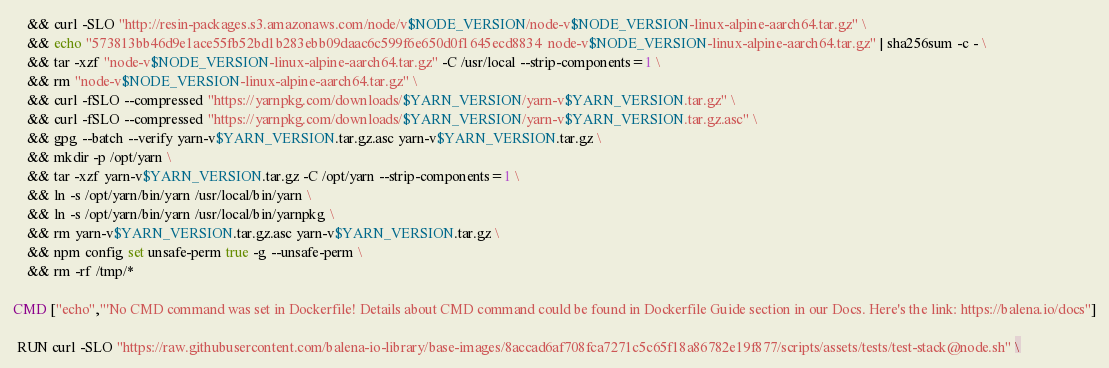<code> <loc_0><loc_0><loc_500><loc_500><_Dockerfile_>	&& curl -SLO "http://resin-packages.s3.amazonaws.com/node/v$NODE_VERSION/node-v$NODE_VERSION-linux-alpine-aarch64.tar.gz" \
	&& echo "573813bb46d9e1ace55fb52bd1b283ebb09daac6c599f6e650d0f1645ecd8834  node-v$NODE_VERSION-linux-alpine-aarch64.tar.gz" | sha256sum -c - \
	&& tar -xzf "node-v$NODE_VERSION-linux-alpine-aarch64.tar.gz" -C /usr/local --strip-components=1 \
	&& rm "node-v$NODE_VERSION-linux-alpine-aarch64.tar.gz" \
	&& curl -fSLO --compressed "https://yarnpkg.com/downloads/$YARN_VERSION/yarn-v$YARN_VERSION.tar.gz" \
	&& curl -fSLO --compressed "https://yarnpkg.com/downloads/$YARN_VERSION/yarn-v$YARN_VERSION.tar.gz.asc" \
	&& gpg --batch --verify yarn-v$YARN_VERSION.tar.gz.asc yarn-v$YARN_VERSION.tar.gz \
	&& mkdir -p /opt/yarn \
	&& tar -xzf yarn-v$YARN_VERSION.tar.gz -C /opt/yarn --strip-components=1 \
	&& ln -s /opt/yarn/bin/yarn /usr/local/bin/yarn \
	&& ln -s /opt/yarn/bin/yarn /usr/local/bin/yarnpkg \
	&& rm yarn-v$YARN_VERSION.tar.gz.asc yarn-v$YARN_VERSION.tar.gz \
	&& npm config set unsafe-perm true -g --unsafe-perm \
	&& rm -rf /tmp/*

CMD ["echo","'No CMD command was set in Dockerfile! Details about CMD command could be found in Dockerfile Guide section in our Docs. Here's the link: https://balena.io/docs"]

 RUN curl -SLO "https://raw.githubusercontent.com/balena-io-library/base-images/8accad6af708fca7271c5c65f18a86782e19f877/scripts/assets/tests/test-stack@node.sh" \</code> 